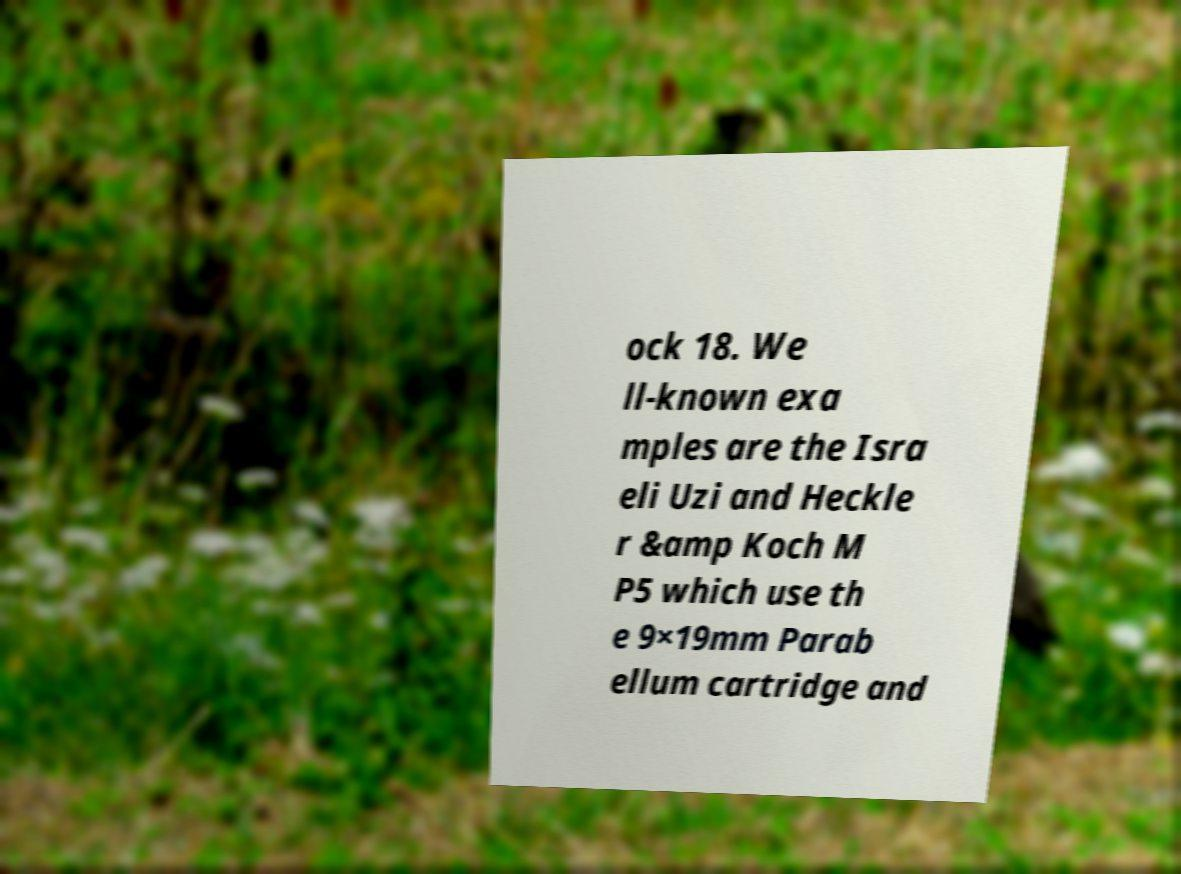What messages or text are displayed in this image? I need them in a readable, typed format. ock 18. We ll-known exa mples are the Isra eli Uzi and Heckle r &amp Koch M P5 which use th e 9×19mm Parab ellum cartridge and 